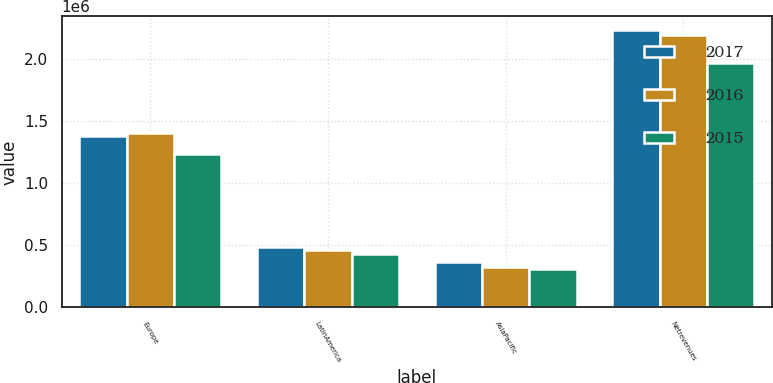Convert chart to OTSL. <chart><loc_0><loc_0><loc_500><loc_500><stacked_bar_chart><ecel><fcel>Europe<fcel>LatinAmerica<fcel>AsiaPacific<fcel>Netrevenues<nl><fcel>2017<fcel>1.38195e+06<fcel>485088<fcel>366542<fcel>2.23358e+06<nl><fcel>2016<fcel>1.40448e+06<fcel>463638<fcel>326535<fcel>2.19465e+06<nl><fcel>2015<fcel>1.23685e+06<fcel>426109<fcel>308920<fcel>1.97188e+06<nl></chart> 